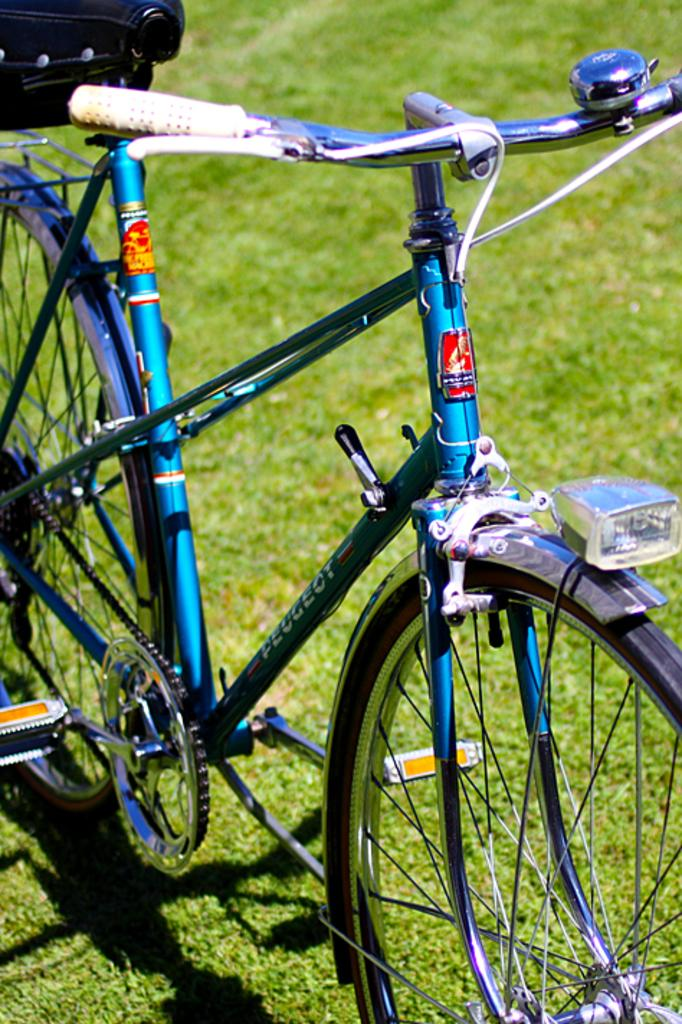What is the main object in the image? There is a bicycle in the image. Where is the bicycle located? The bicycle is on the surface of the grass. What is the reason for the stream flowing in the image? There is no stream present in the image; it only features a bicycle on the grass. 